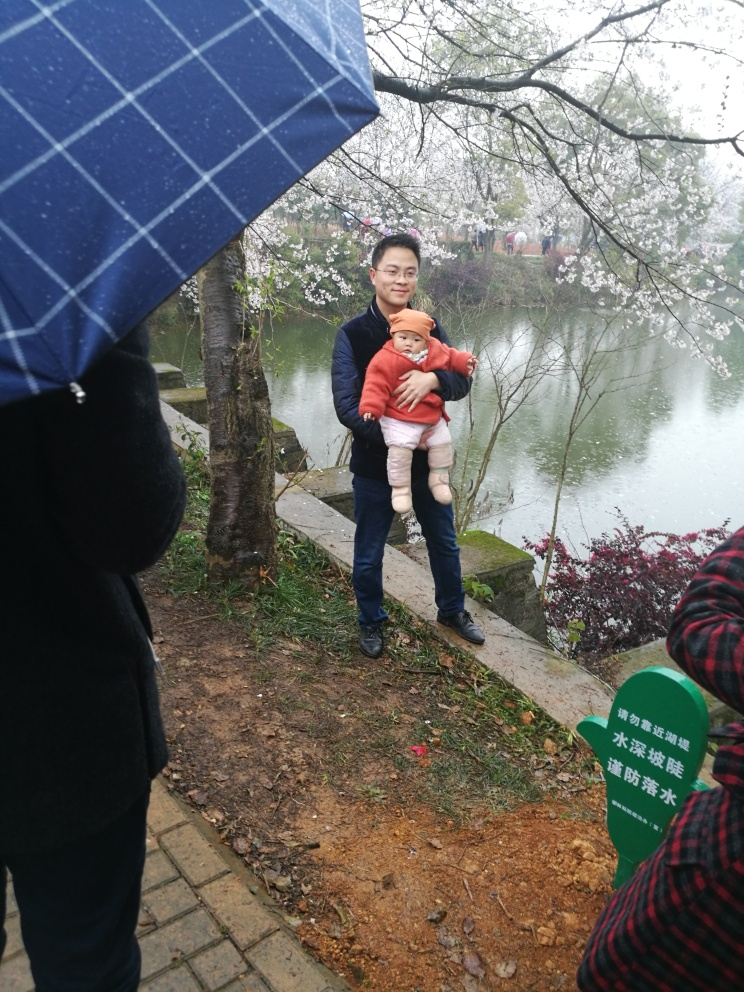Can you describe the potential relationship between the person and the child in the image? Given the close physical proximity and the manner in which the child is being held, it's likely that there is a familial bond. The person could be a parent or guardian, as there is a sense of protection and comfort in the way the child is cradled. 